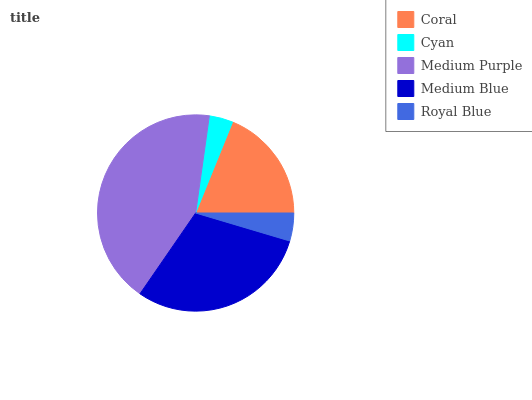Is Cyan the minimum?
Answer yes or no. Yes. Is Medium Purple the maximum?
Answer yes or no. Yes. Is Medium Purple the minimum?
Answer yes or no. No. Is Cyan the maximum?
Answer yes or no. No. Is Medium Purple greater than Cyan?
Answer yes or no. Yes. Is Cyan less than Medium Purple?
Answer yes or no. Yes. Is Cyan greater than Medium Purple?
Answer yes or no. No. Is Medium Purple less than Cyan?
Answer yes or no. No. Is Coral the high median?
Answer yes or no. Yes. Is Coral the low median?
Answer yes or no. Yes. Is Medium Purple the high median?
Answer yes or no. No. Is Royal Blue the low median?
Answer yes or no. No. 